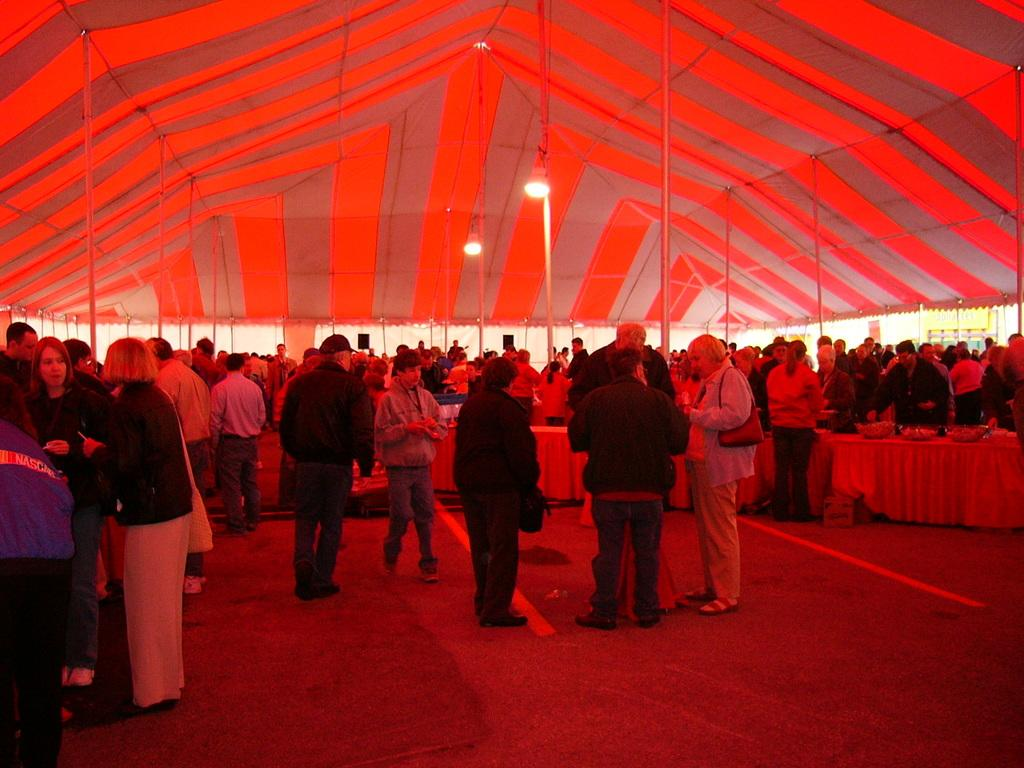How many people are present in the image? There are many people in the image. What structure can be seen above the people in the image? The people are standing under a huge tent. What type of furniture is visible in the image? There are tables in the image. Where are the people located in relation to the tables? People are standing near the tables. What type of spring can be seen in the image? There is no spring present in the image. Can you describe the twig that is being used as a decoration in the image? There is no twig present in the image. 